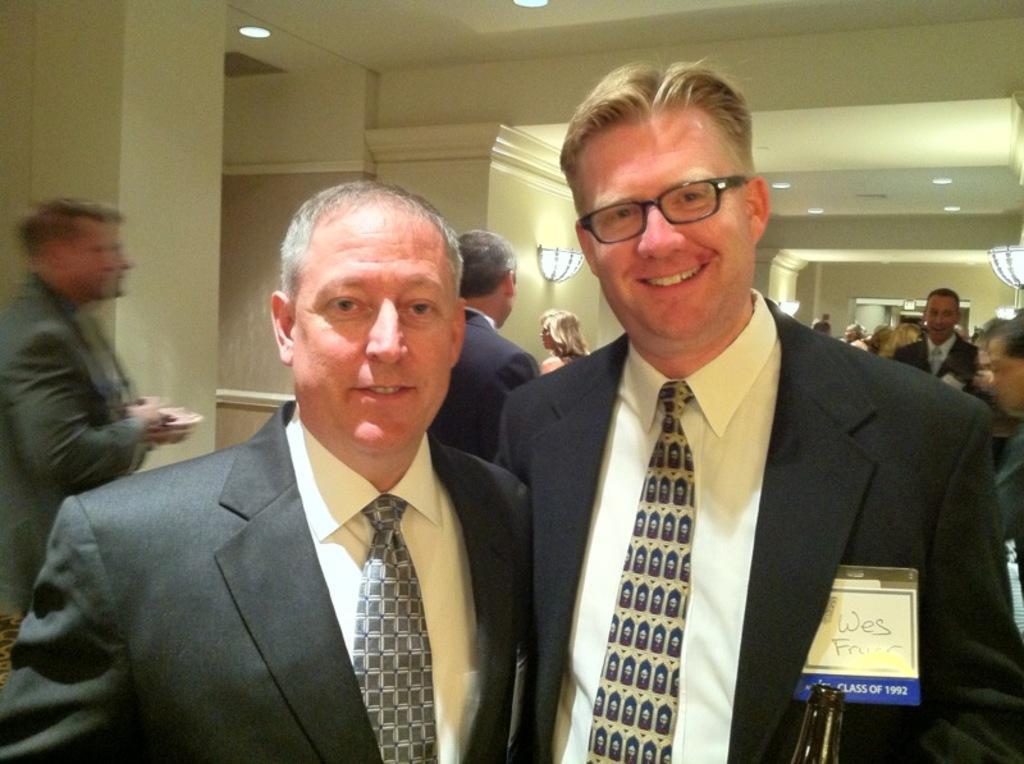In one or two sentences, can you explain what this image depicts? In this image I can see two persons standing. The person at right wearing black color blazer, white shirt and the person at left wearing gray blazer and white shirt. Background I can see few other persons standing, wall in cream color. 